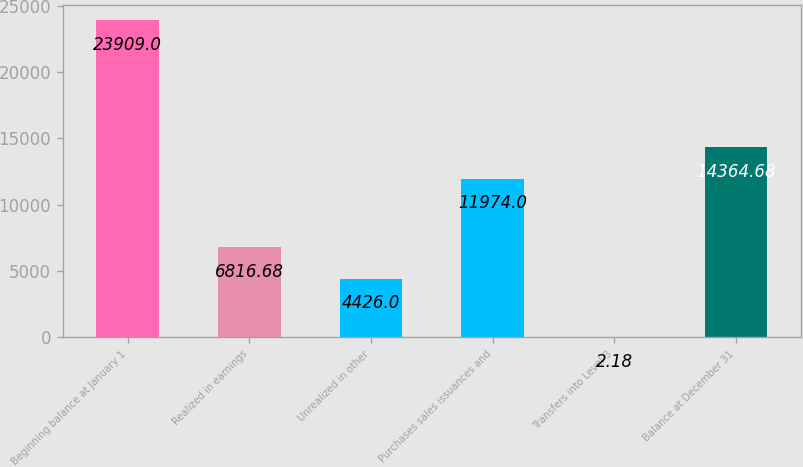Convert chart. <chart><loc_0><loc_0><loc_500><loc_500><bar_chart><fcel>Beginning balance at January 1<fcel>Realized in earnings<fcel>Unrealized in other<fcel>Purchases sales issuances and<fcel>Transfers into Level 3<fcel>Balance at December 31<nl><fcel>23909<fcel>6816.68<fcel>4426<fcel>11974<fcel>2.18<fcel>14364.7<nl></chart> 